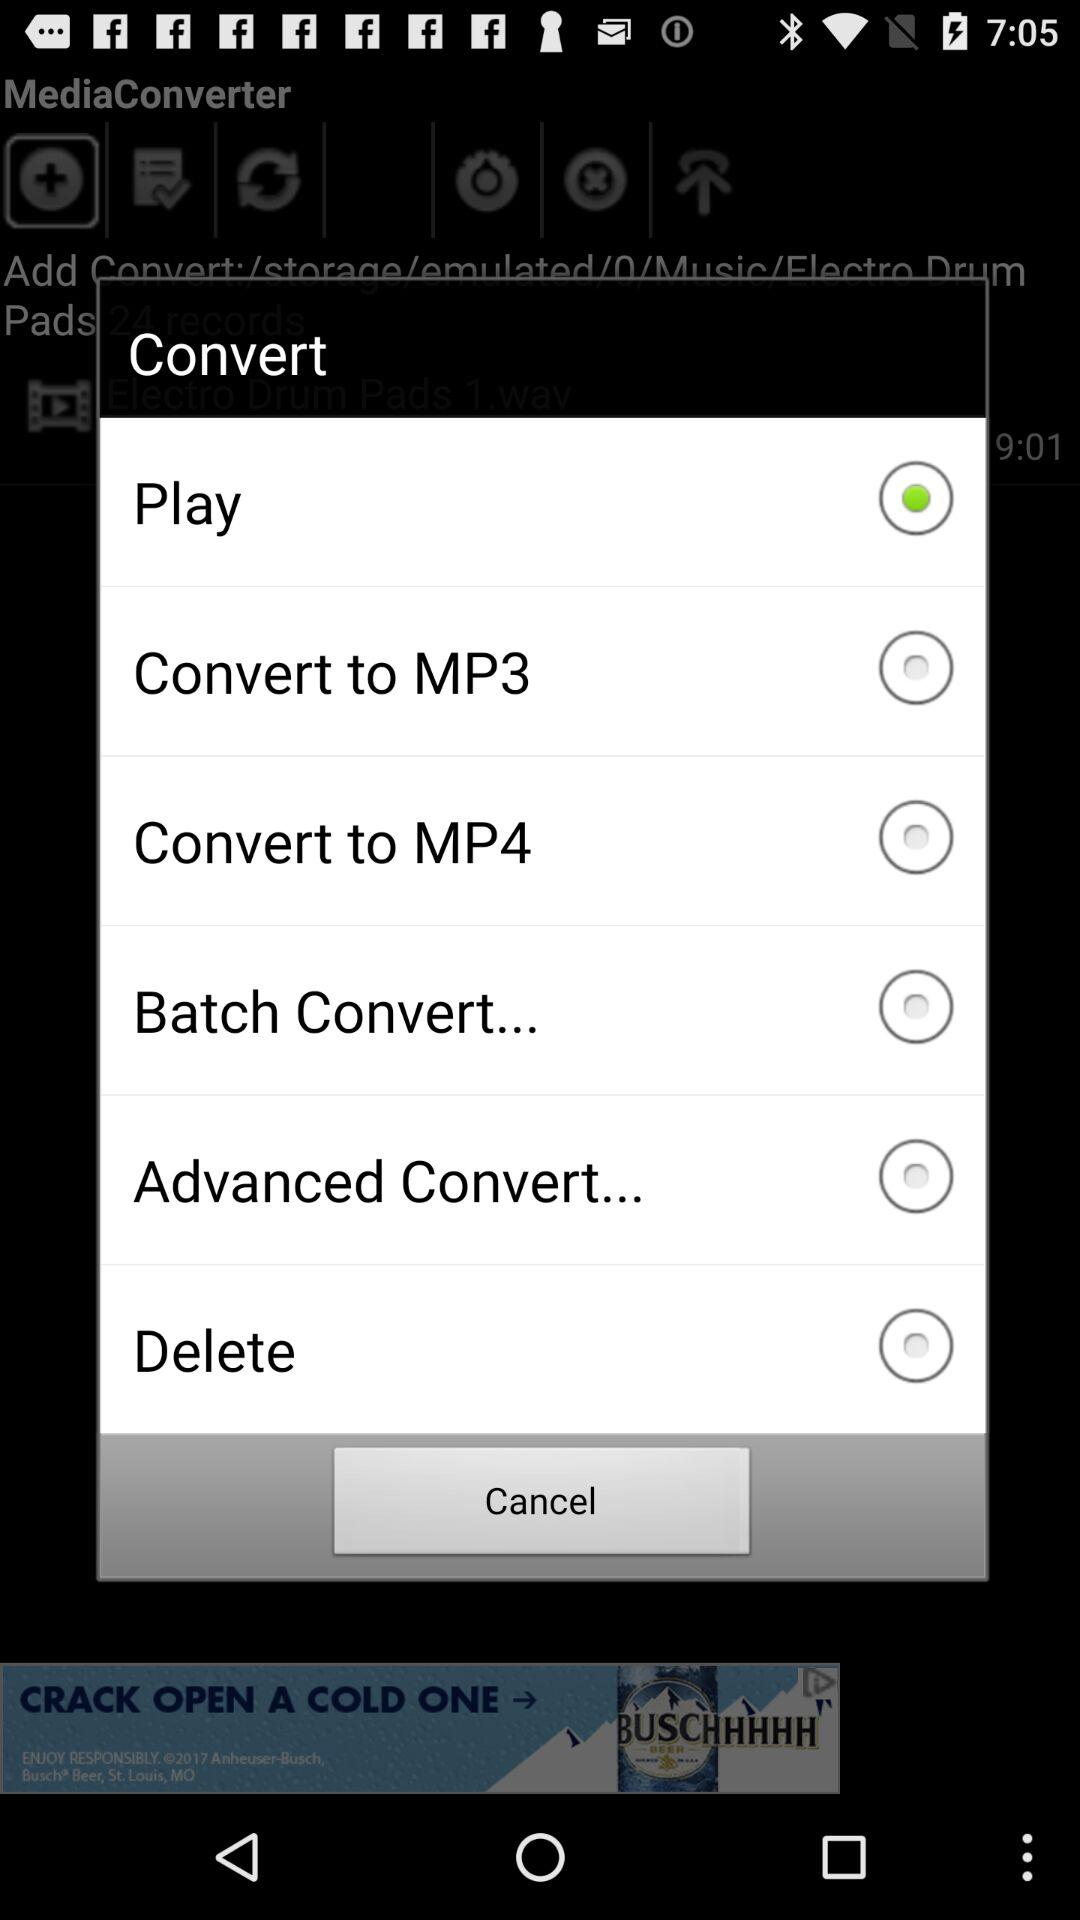Which is the selected option? The selected option is "Play". 